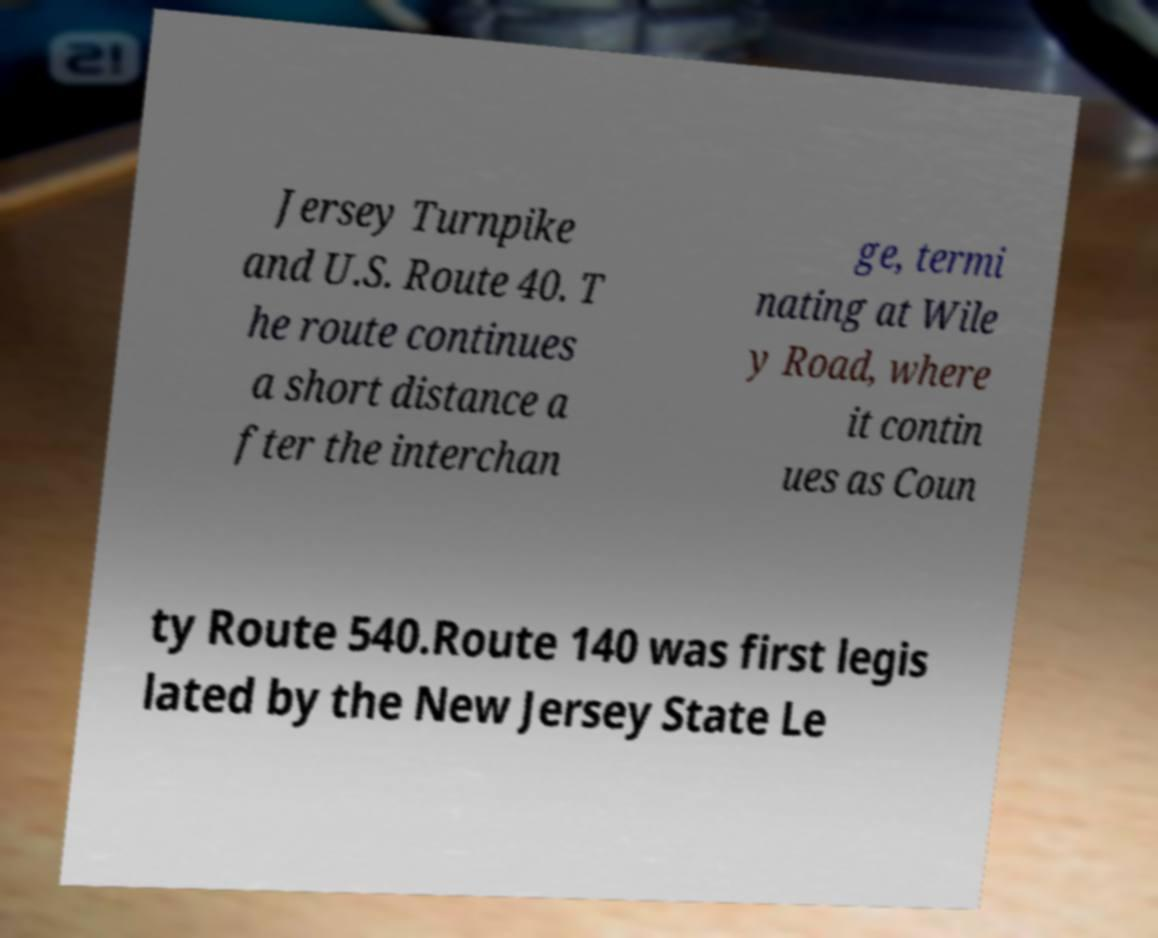For documentation purposes, I need the text within this image transcribed. Could you provide that? Jersey Turnpike and U.S. Route 40. T he route continues a short distance a fter the interchan ge, termi nating at Wile y Road, where it contin ues as Coun ty Route 540.Route 140 was first legis lated by the New Jersey State Le 